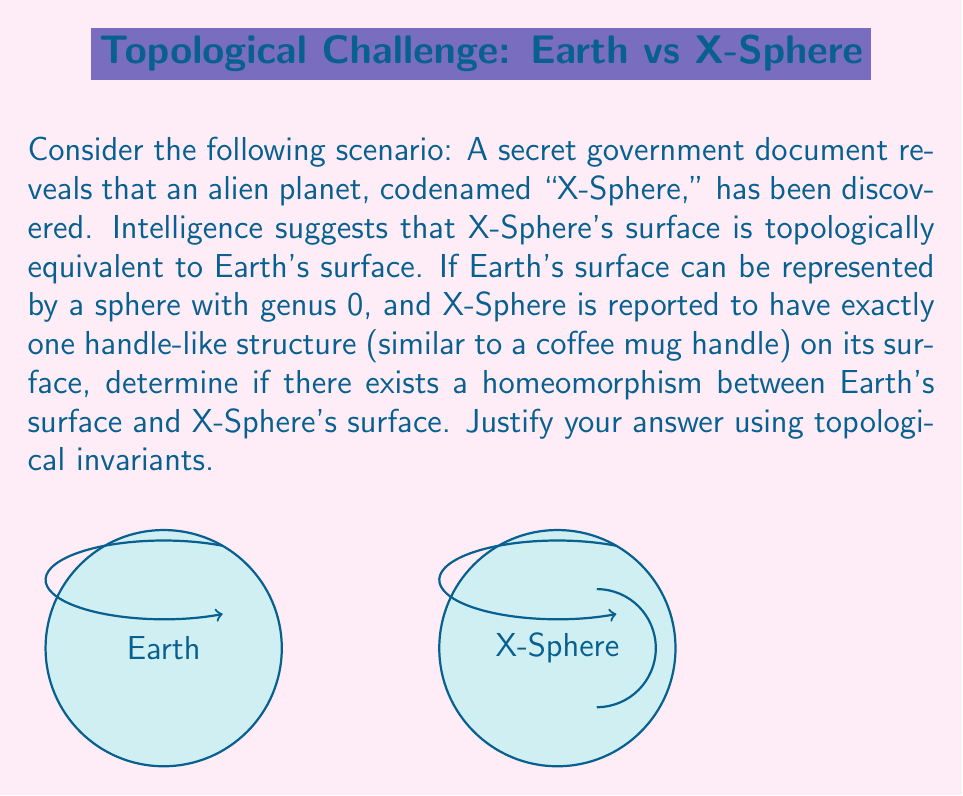Show me your answer to this math problem. To determine if there exists a homeomorphism between Earth's surface and X-Sphere's surface, we need to consider the topological invariants of both surfaces. The most relevant invariant in this case is the genus of the surface.

Step 1: Identify Earth's topological properties
Earth's surface is represented by a sphere with genus 0. In topology, a sphere is denoted as $S^2$.

Step 2: Analyze X-Sphere's topological properties
X-Sphere is reported to have one handle-like structure on its surface. In topological terms, this is equivalent to a torus, which has a genus of 1.

Step 3: Compare the genera
The genus is a topological invariant, meaning it remains unchanged under homeomorphisms. 
- Earth's genus: $g_E = 0$
- X-Sphere's genus: $g_X = 1$

Step 4: Apply the homeomorphism principle
For two surfaces to be homeomorphic, they must have the same genus. Since $g_E \neq g_X$, we can conclude that Earth's surface and X-Sphere's surface are not homeomorphic.

Step 5: Interpret the result
This means that there is no continuous bijective function with a continuous inverse that can map Earth's surface to X-Sphere's surface while preserving their topological properties.

Step 6: Formal representation
We can represent this conclusion mathematically as:

$$ \nexists f : S^2 \rightarrow T^2 \text{ such that } f \text{ is a homeomorphism} $$

Where $S^2$ represents Earth (a 2-sphere) and $T^2$ represents X-Sphere (a torus).
Answer: No homeomorphism exists; genera differ (0 ≠ 1). 